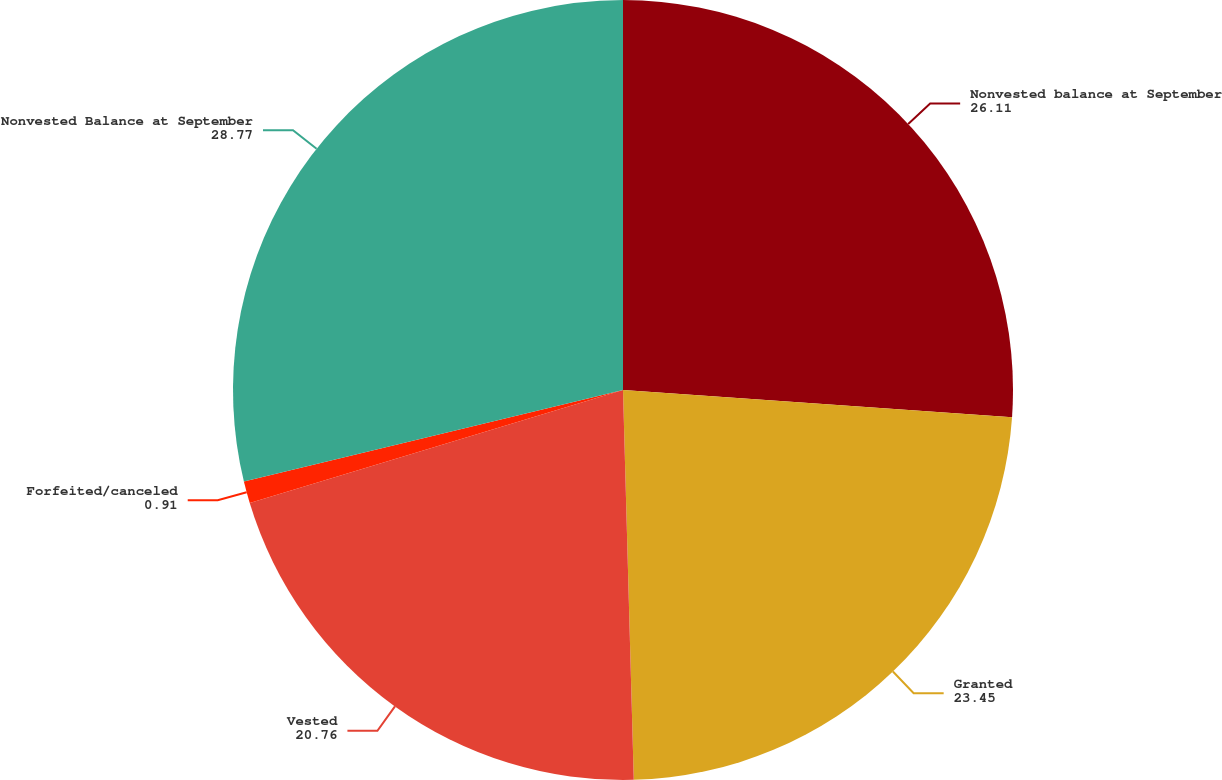Convert chart. <chart><loc_0><loc_0><loc_500><loc_500><pie_chart><fcel>Nonvested balance at September<fcel>Granted<fcel>Vested<fcel>Forfeited/canceled<fcel>Nonvested Balance at September<nl><fcel>26.11%<fcel>23.45%<fcel>20.76%<fcel>0.91%<fcel>28.77%<nl></chart> 